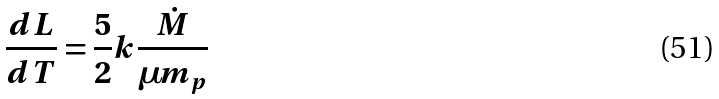Convert formula to latex. <formula><loc_0><loc_0><loc_500><loc_500>\frac { d L } { d T } = \frac { 5 } { 2 } k \frac { \dot { M } } { \mu m _ { p } }</formula> 